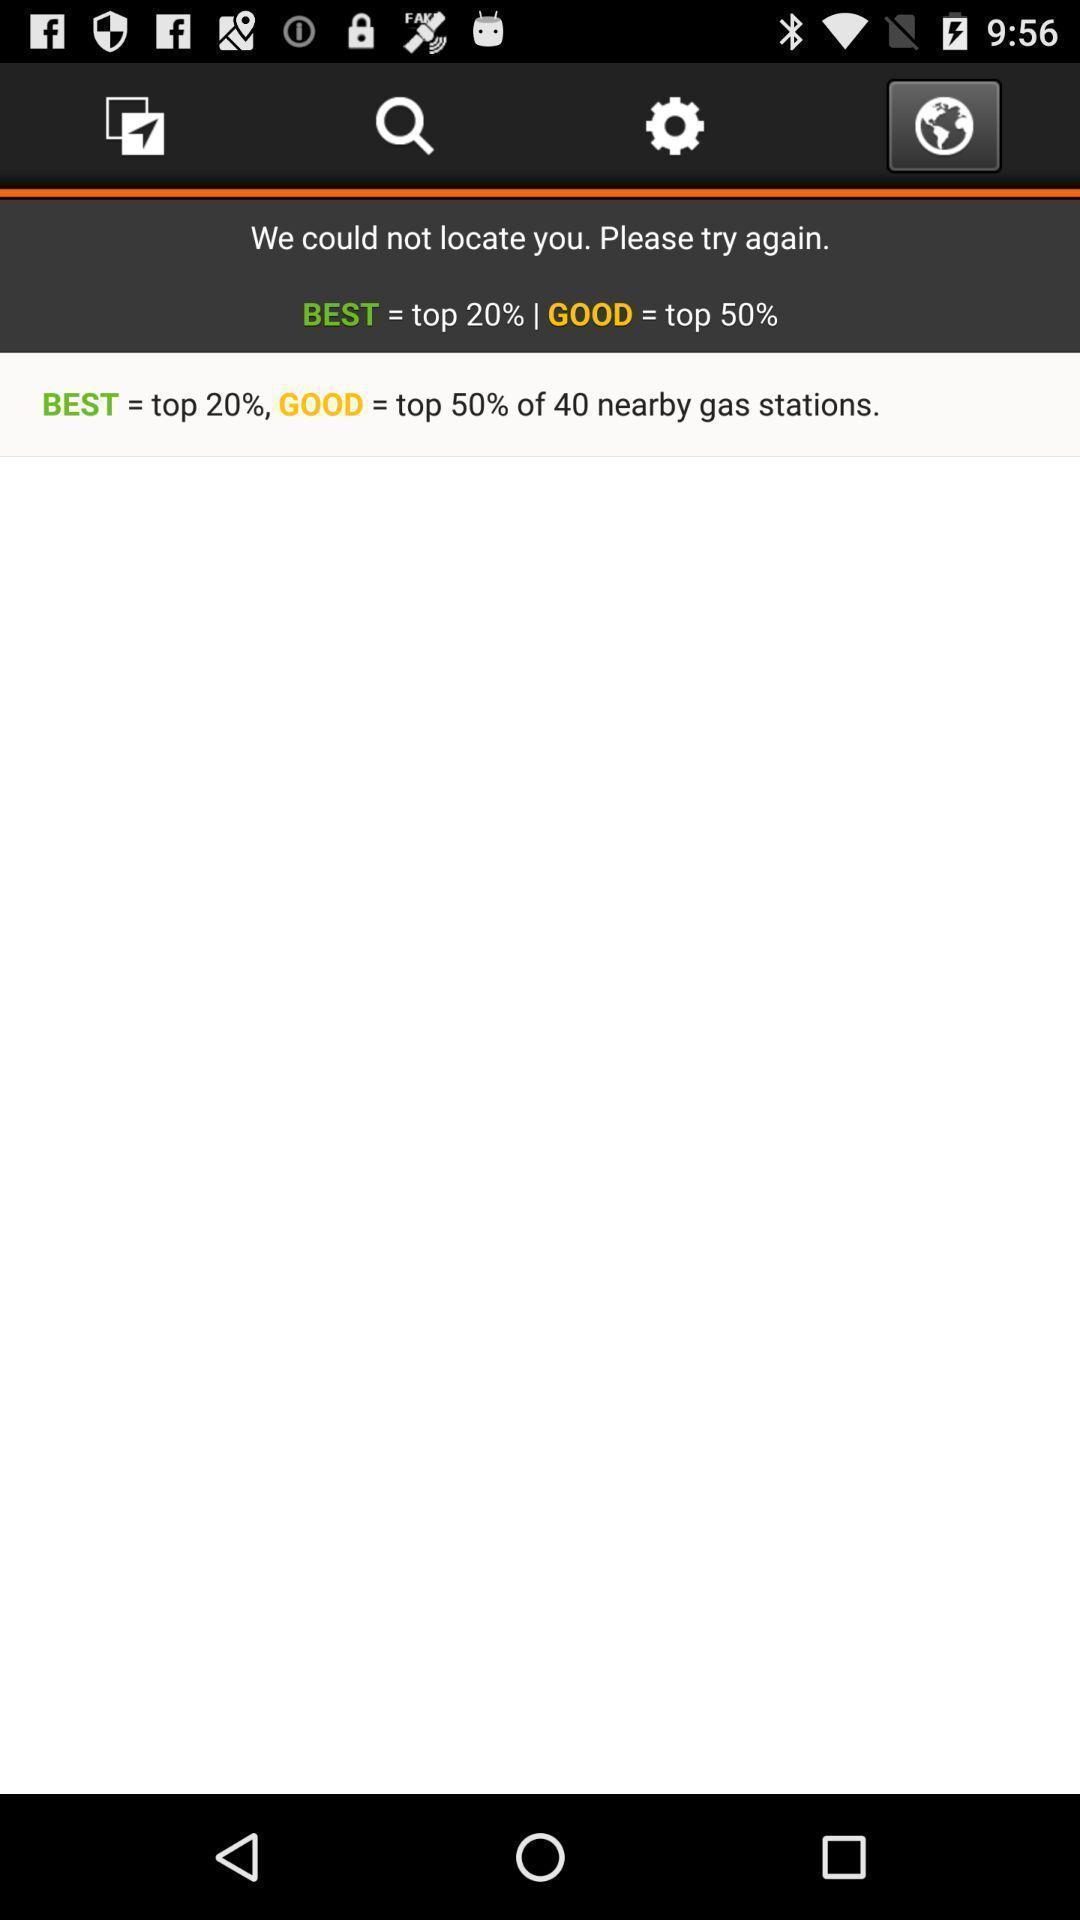Provide a description of this screenshot. Page displaying information about application with other options. 